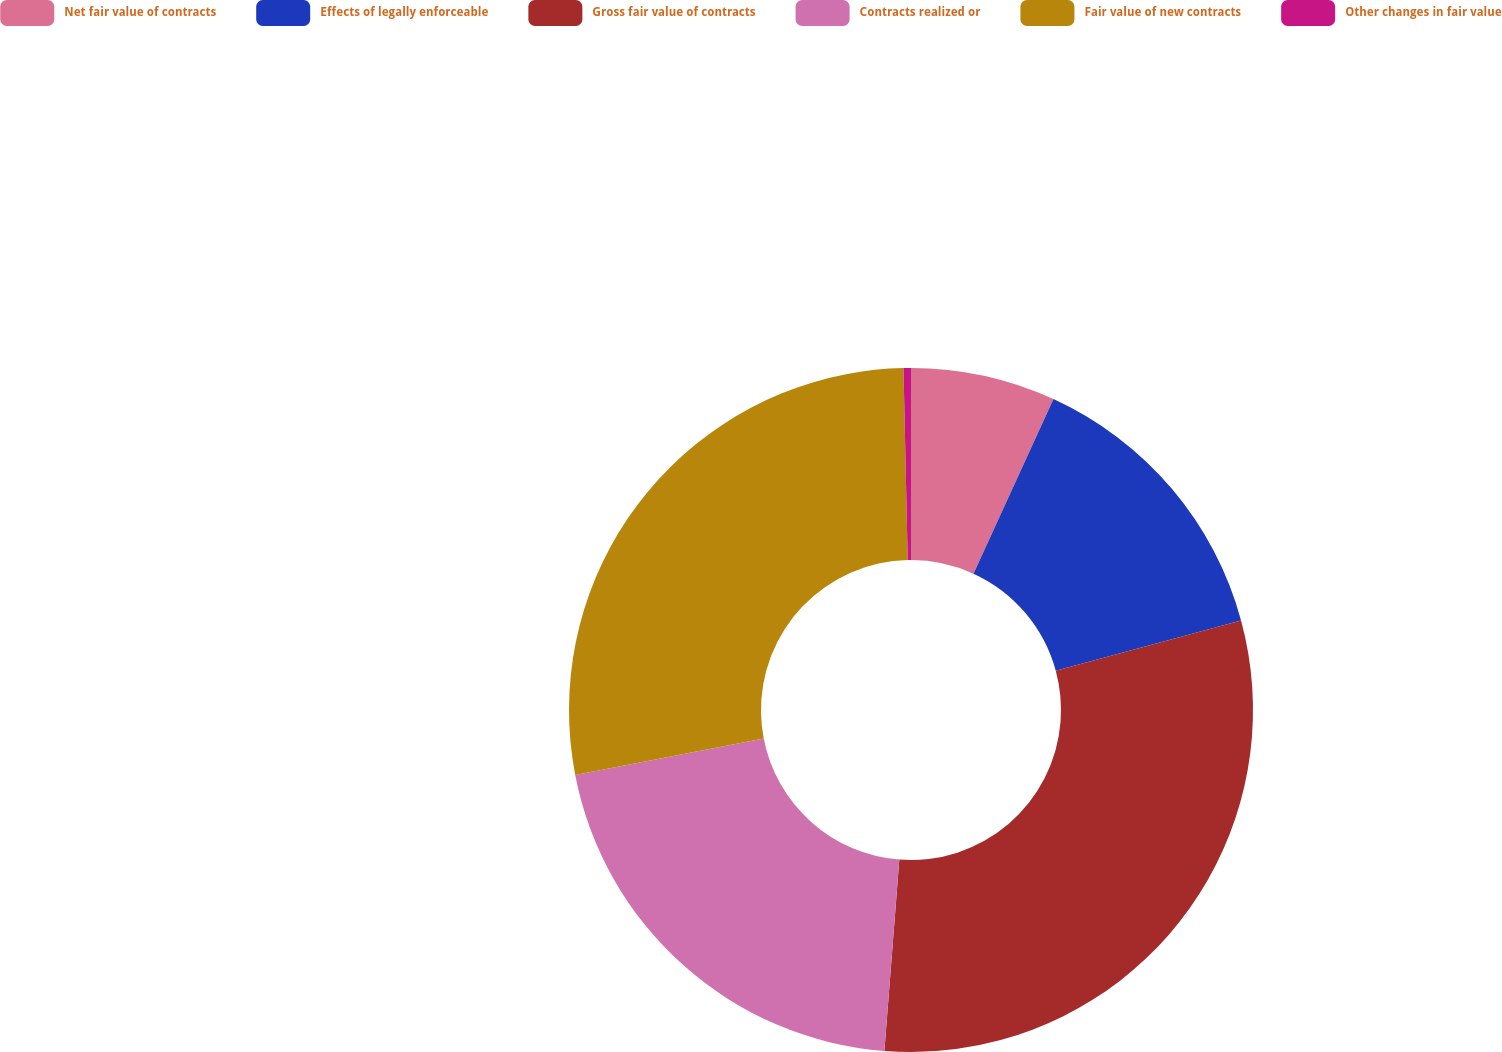<chart> <loc_0><loc_0><loc_500><loc_500><pie_chart><fcel>Net fair value of contracts<fcel>Effects of legally enforceable<fcel>Gross fair value of contracts<fcel>Contracts realized or<fcel>Fair value of new contracts<fcel>Other changes in fair value<nl><fcel>6.84%<fcel>13.94%<fcel>30.46%<fcel>20.72%<fcel>27.69%<fcel>0.35%<nl></chart> 